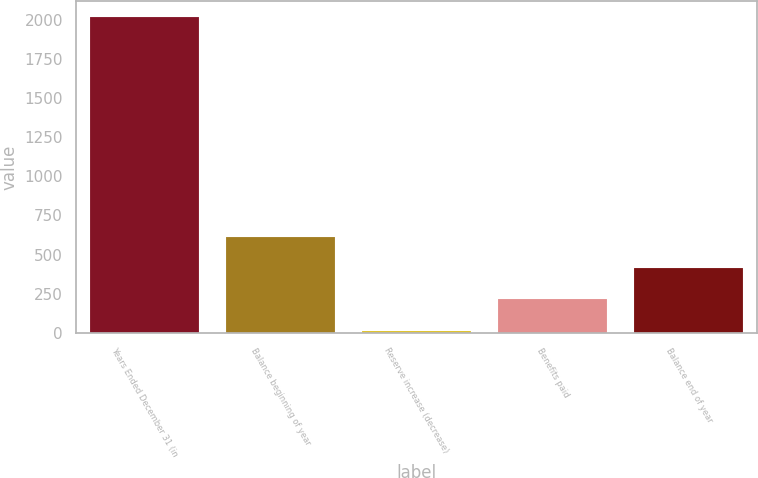Convert chart to OTSL. <chart><loc_0><loc_0><loc_500><loc_500><bar_chart><fcel>Years Ended December 31 (in<fcel>Balance beginning of year<fcel>Reserve increase (decrease)<fcel>Benefits paid<fcel>Balance end of year<nl><fcel>2017<fcel>614.9<fcel>14<fcel>214.3<fcel>414.6<nl></chart> 